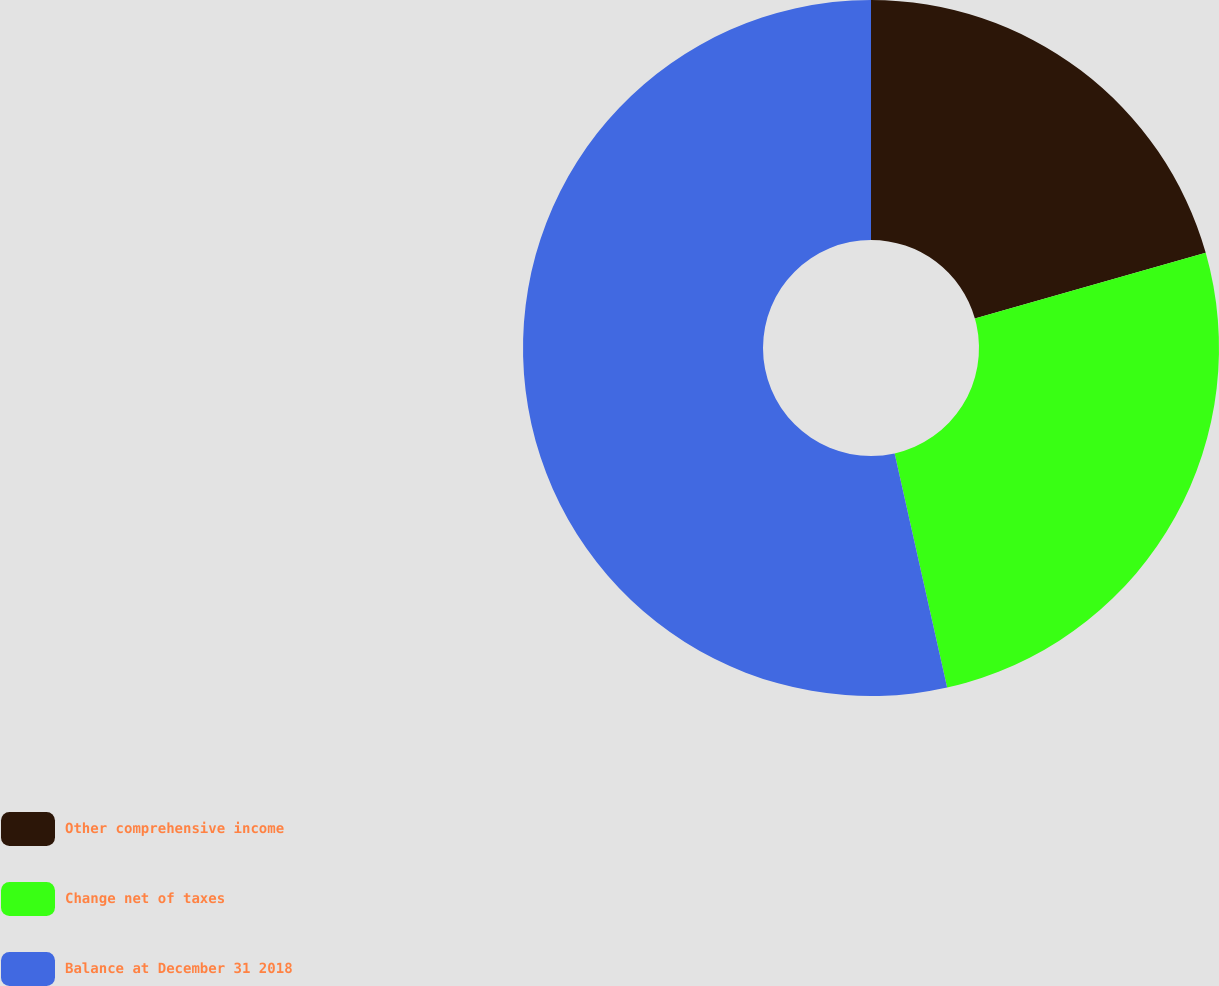Convert chart to OTSL. <chart><loc_0><loc_0><loc_500><loc_500><pie_chart><fcel>Other comprehensive income<fcel>Change net of taxes<fcel>Balance at December 31 2018<nl><fcel>20.59%<fcel>25.9%<fcel>53.51%<nl></chart> 